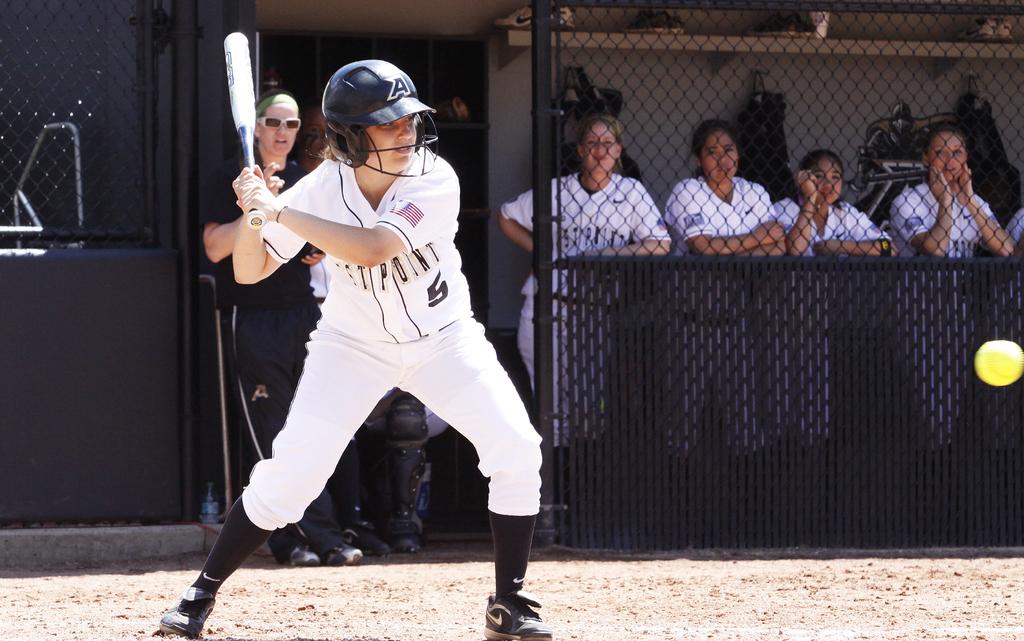What is the last word on the jersey?
Offer a terse response. Point. 